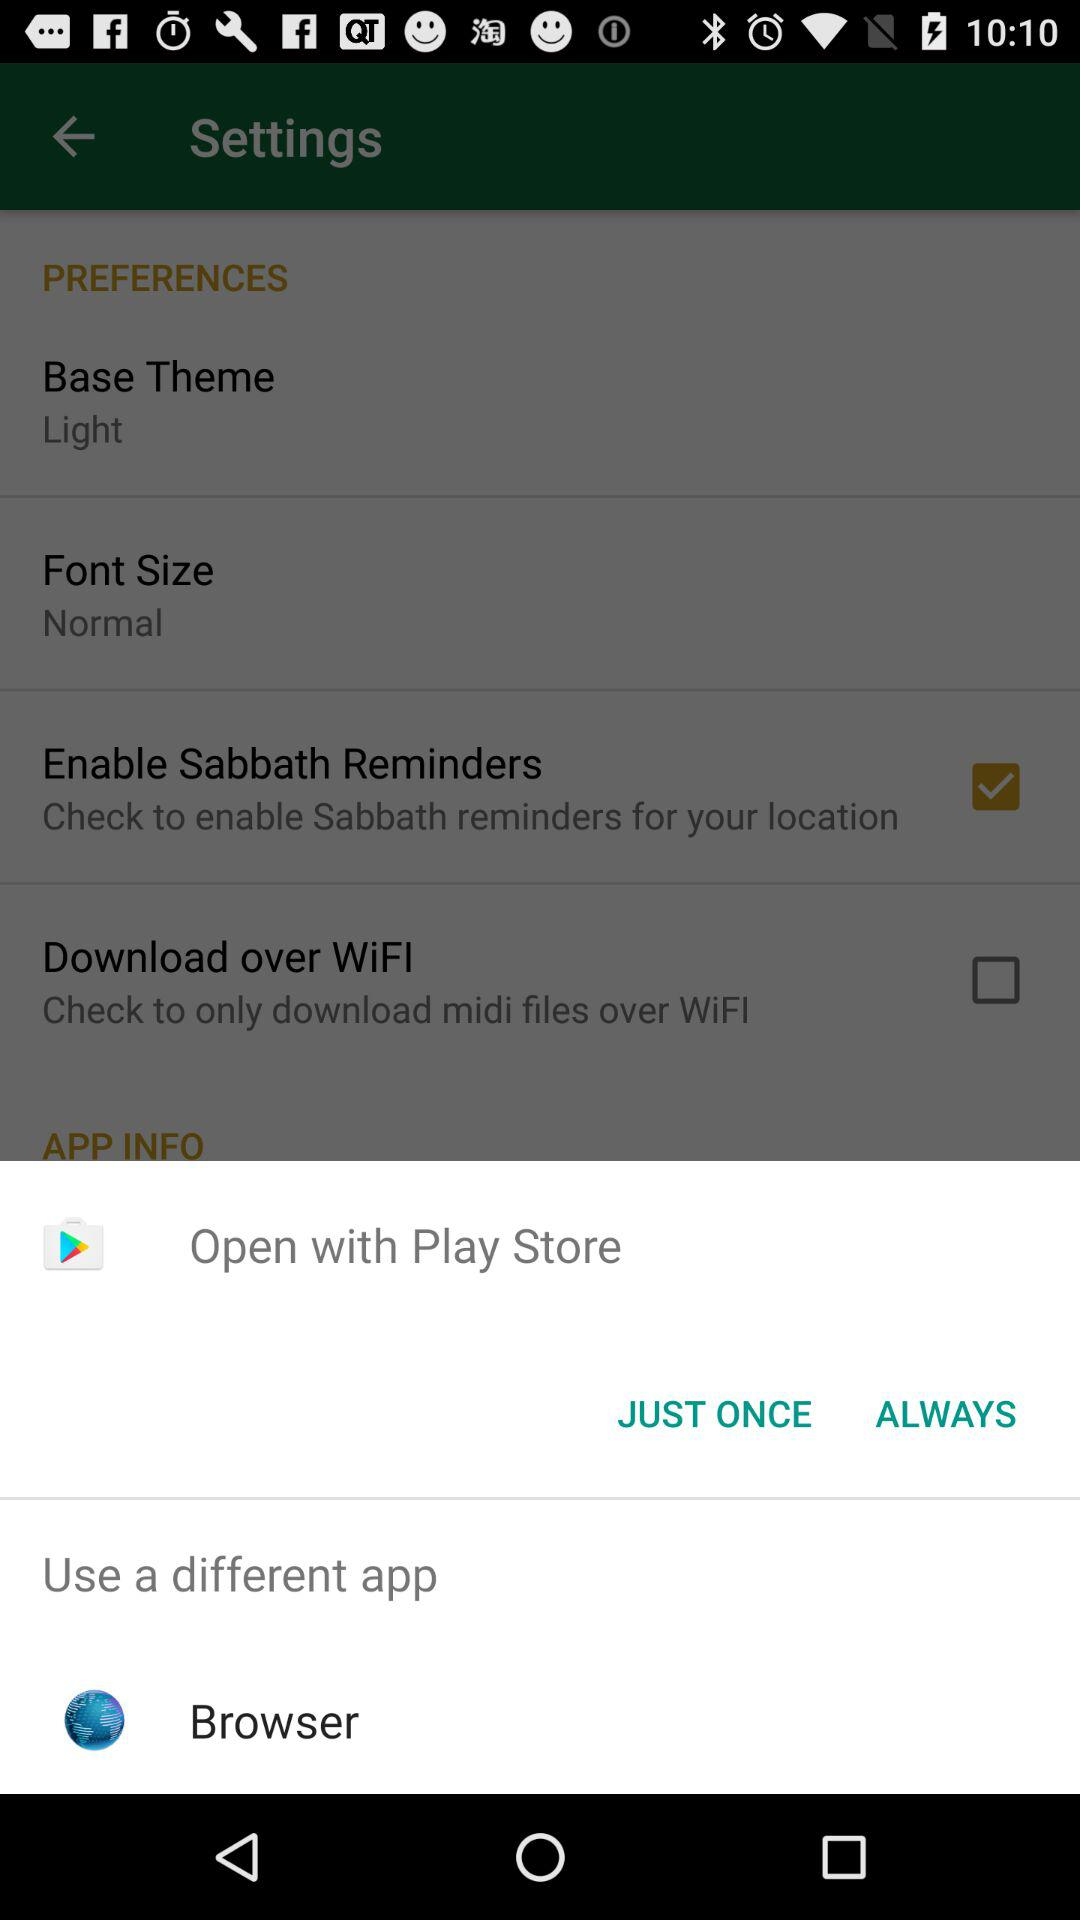How many checkboxes are in the preferences menu?
Answer the question using a single word or phrase. 2 